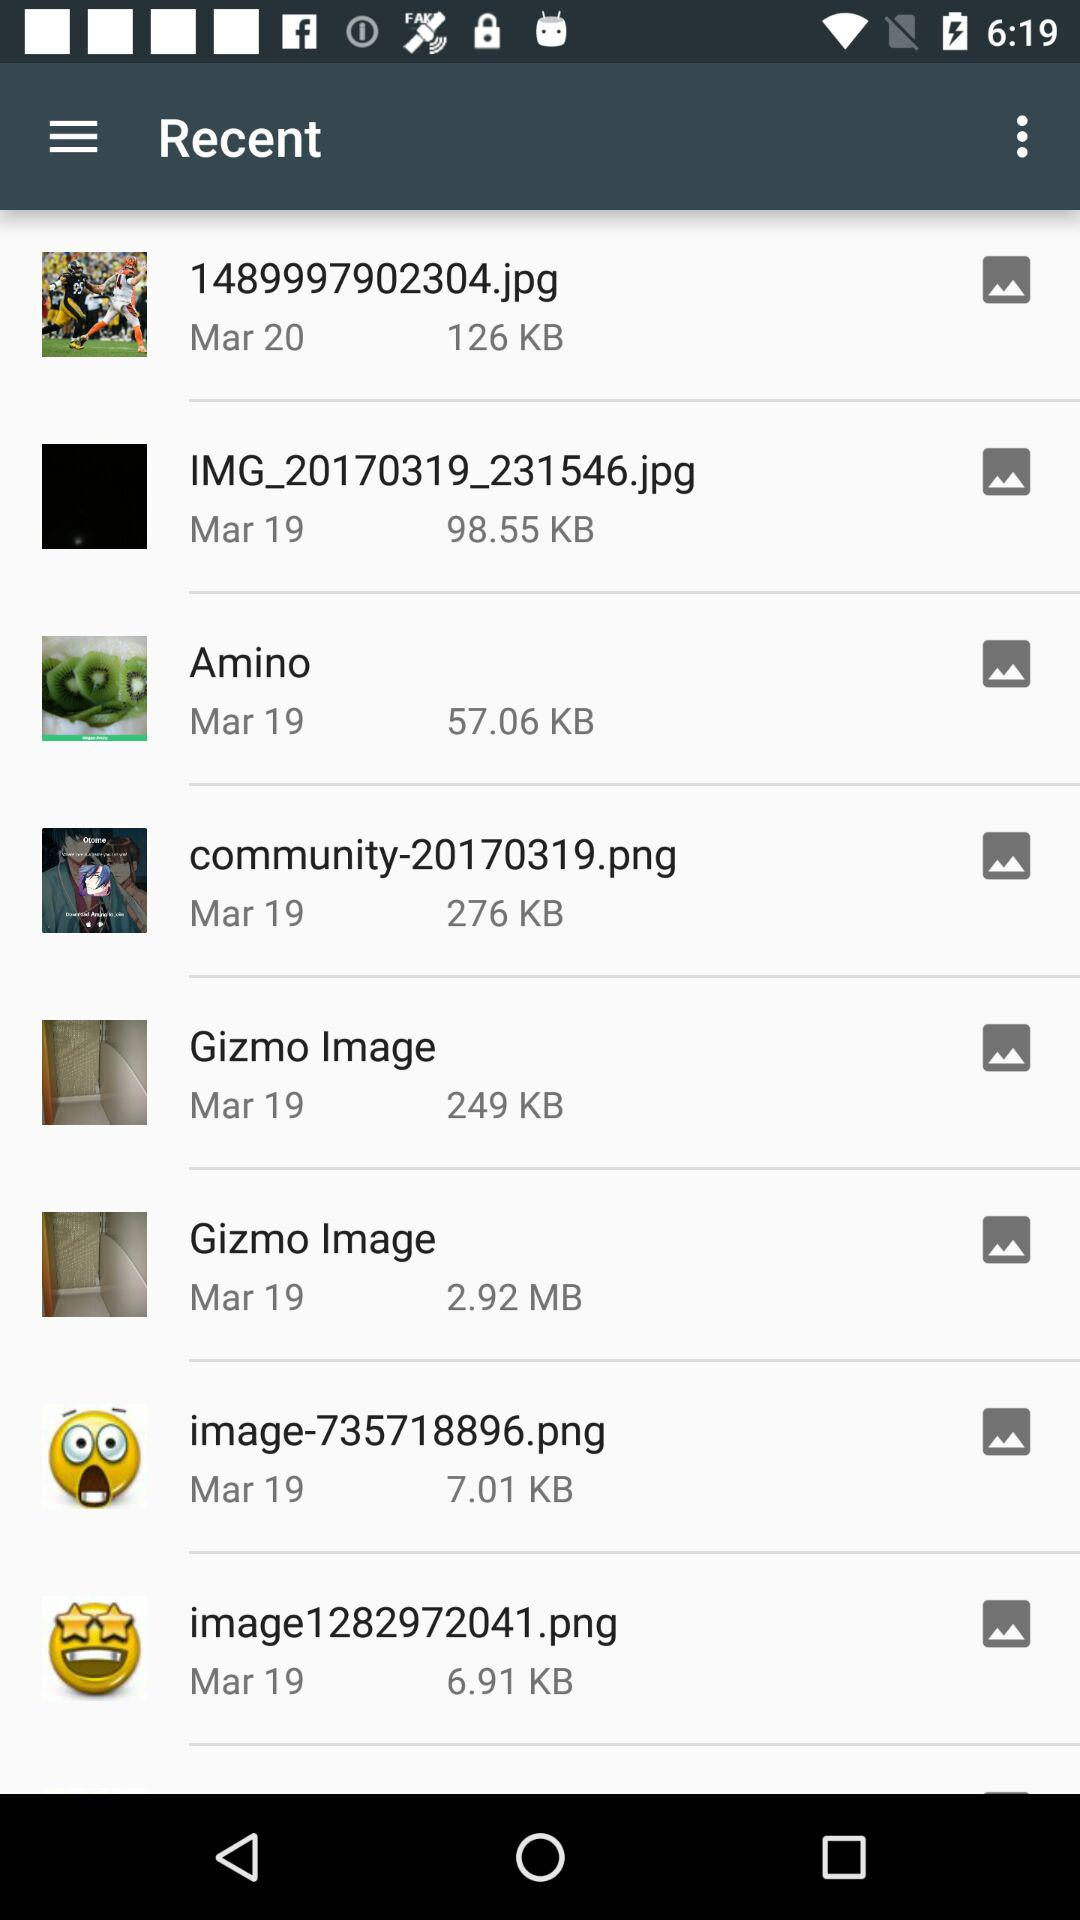Which date is given for "Gizmo Image"? The given date is March 19. 